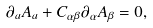<formula> <loc_0><loc_0><loc_500><loc_500>\partial _ { a } A _ { a } + C _ { \alpha \beta } \partial _ { \alpha } A _ { \beta } = 0 ,</formula> 